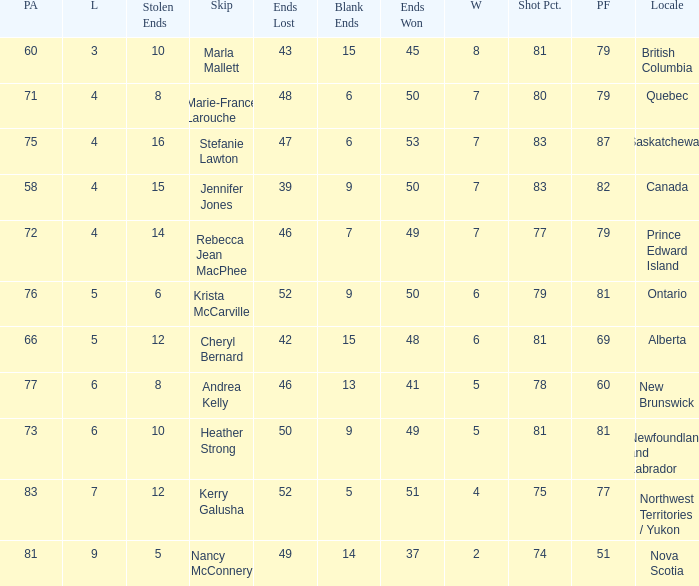What is the total of blank ends at Prince Edward Island? 7.0. 